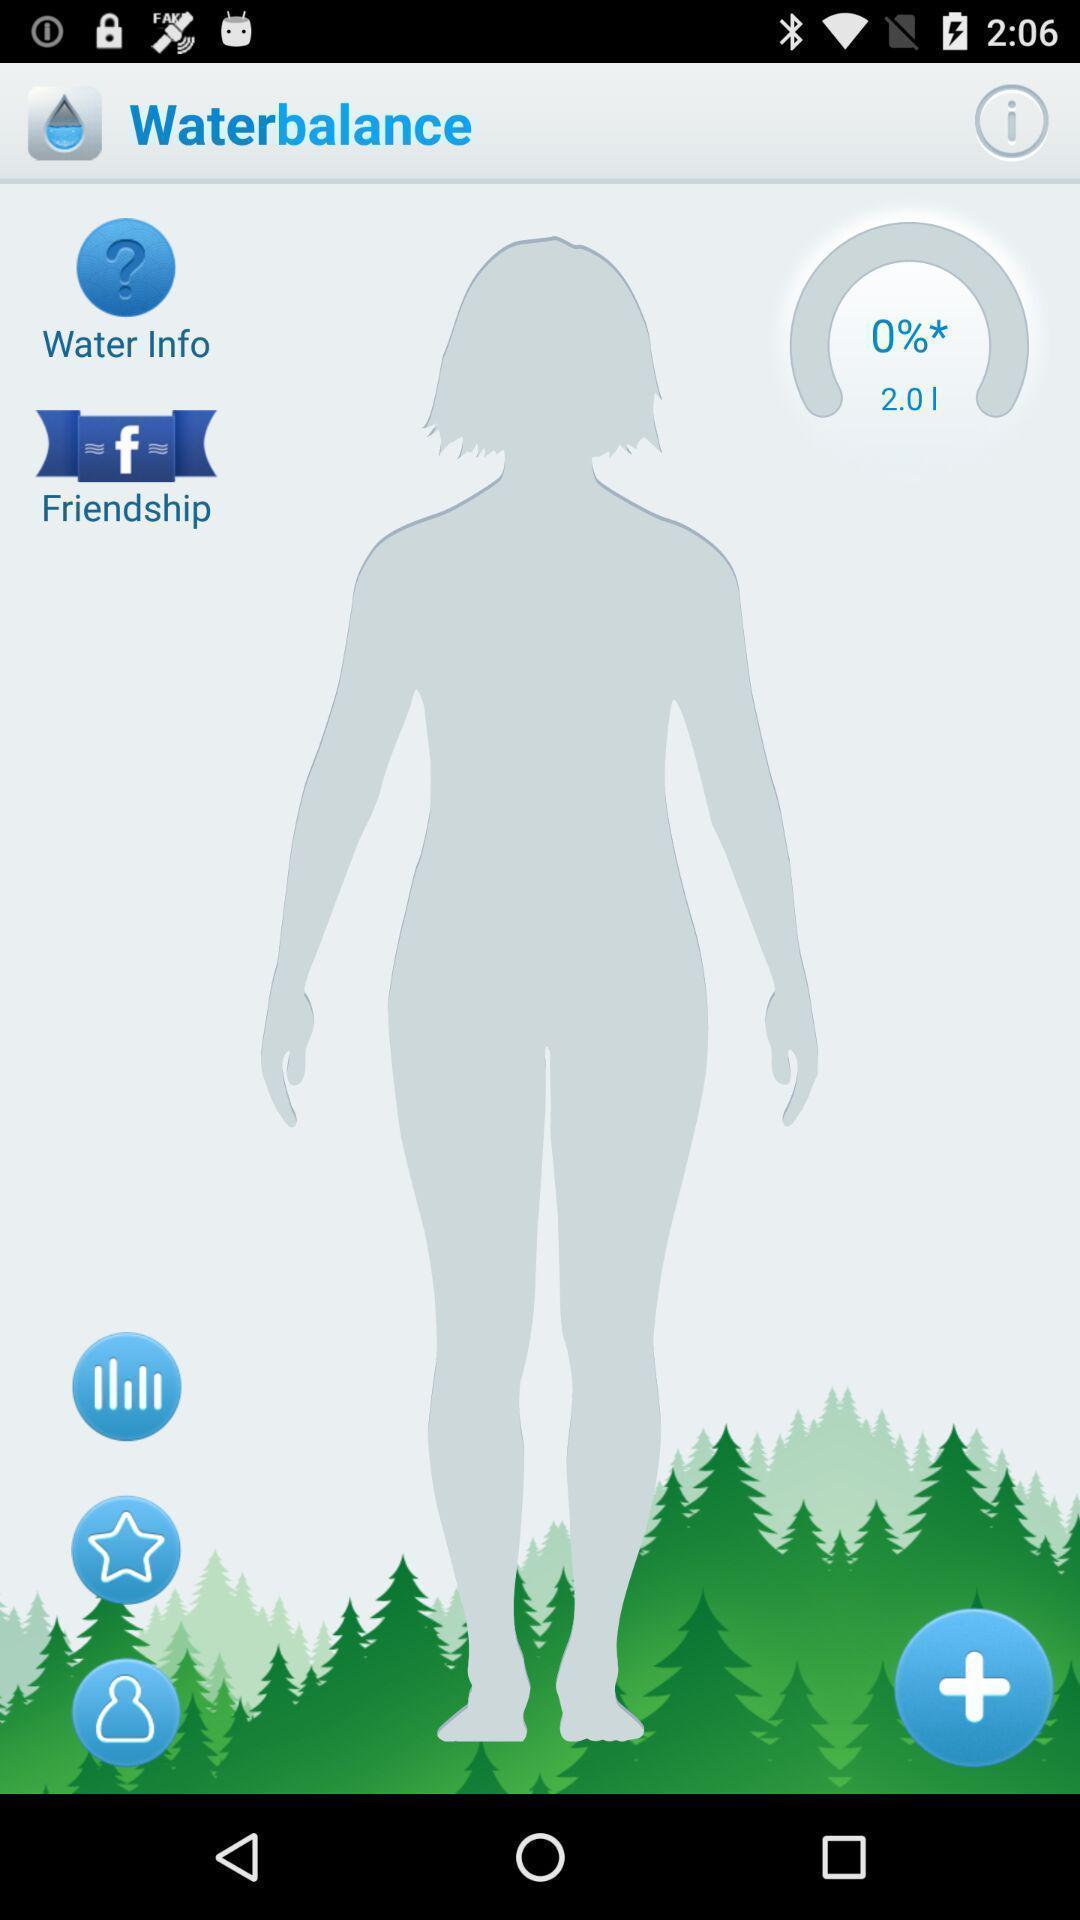Provide a detailed account of this screenshot. Page displaying to track water balance with other features. 